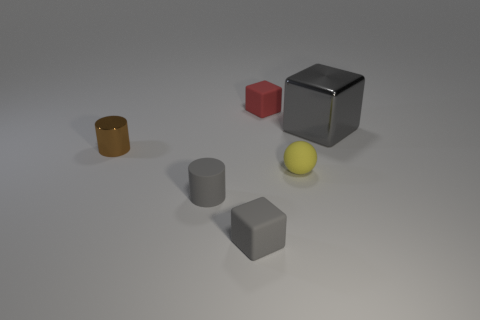Is there a metal thing in front of the rubber block in front of the small yellow sphere?
Ensure brevity in your answer.  No. Does the sphere have the same size as the block left of the small red rubber cube?
Your response must be concise. Yes. There is a gray thing on the right side of the small thing behind the gray shiny cube; is there a tiny gray matte cylinder behind it?
Make the answer very short. No. What material is the block that is to the right of the red cube?
Keep it short and to the point. Metal. Do the metal cube and the yellow rubber object have the same size?
Provide a succinct answer. No. There is a thing that is both on the right side of the gray cylinder and in front of the yellow matte ball; what color is it?
Give a very brief answer. Gray. What is the shape of the brown object that is the same material as the large gray block?
Your answer should be compact. Cylinder. How many tiny things are both to the right of the small gray matte cylinder and in front of the red matte thing?
Your answer should be compact. 2. Are there any tiny red cubes behind the red matte cube?
Make the answer very short. No. There is a small object that is right of the red rubber block; is its shape the same as the metallic object that is behind the tiny metallic object?
Your answer should be very brief. No. 